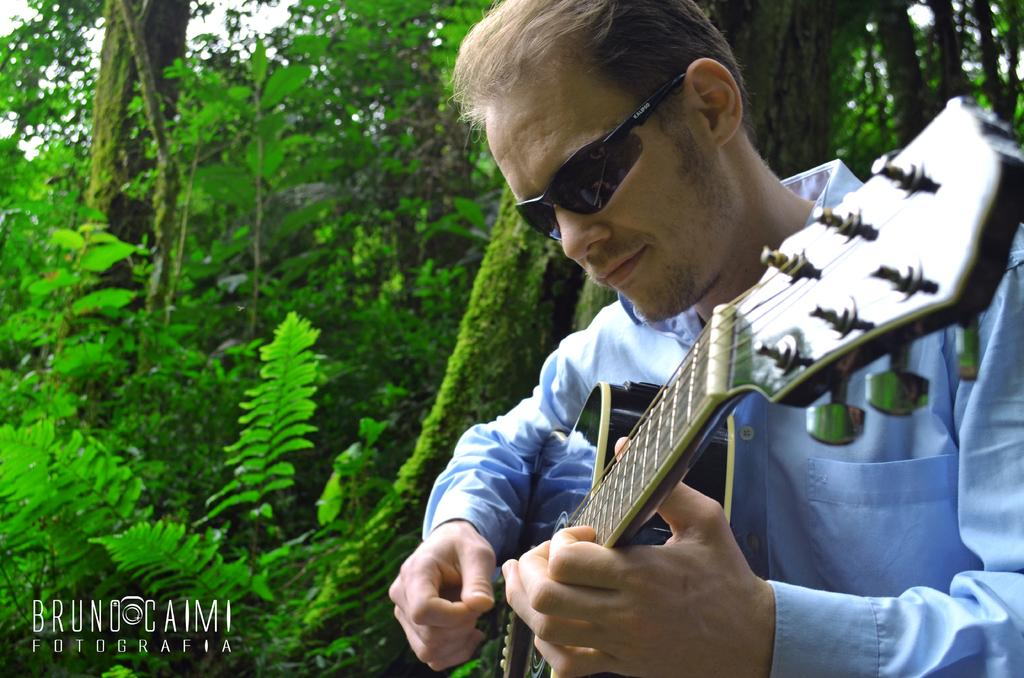Who is in the image? There is a person in the image. What is the person wearing? The person is wearing a blue shirt. What is the person doing in the image? The person is playing a guitar. What can be seen in the background of the image? There are trees beside the person. What type of underwear is the person wearing in the image? The provided facts do not mention any underwear, so it cannot be determined from the image. 